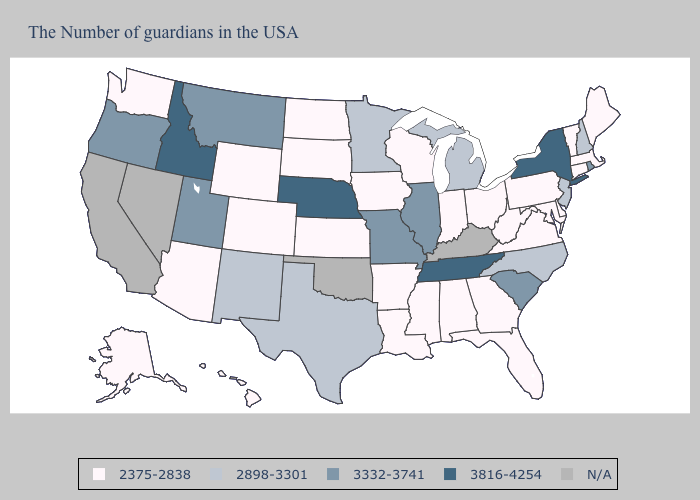What is the value of Alabama?
Concise answer only. 2375-2838. What is the lowest value in states that border Wyoming?
Be succinct. 2375-2838. Is the legend a continuous bar?
Keep it brief. No. What is the highest value in the USA?
Short answer required. 3816-4254. Name the states that have a value in the range 3816-4254?
Be succinct. New York, Tennessee, Nebraska, Idaho. How many symbols are there in the legend?
Concise answer only. 5. Which states have the highest value in the USA?
Quick response, please. New York, Tennessee, Nebraska, Idaho. What is the value of West Virginia?
Be succinct. 2375-2838. What is the lowest value in the Northeast?
Quick response, please. 2375-2838. Which states hav the highest value in the West?
Write a very short answer. Idaho. Among the states that border Montana , which have the highest value?
Keep it brief. Idaho. What is the highest value in the USA?
Answer briefly. 3816-4254. Does Nebraska have the highest value in the USA?
Keep it brief. Yes. Does Alabama have the highest value in the South?
Keep it brief. No. What is the value of Texas?
Quick response, please. 2898-3301. 